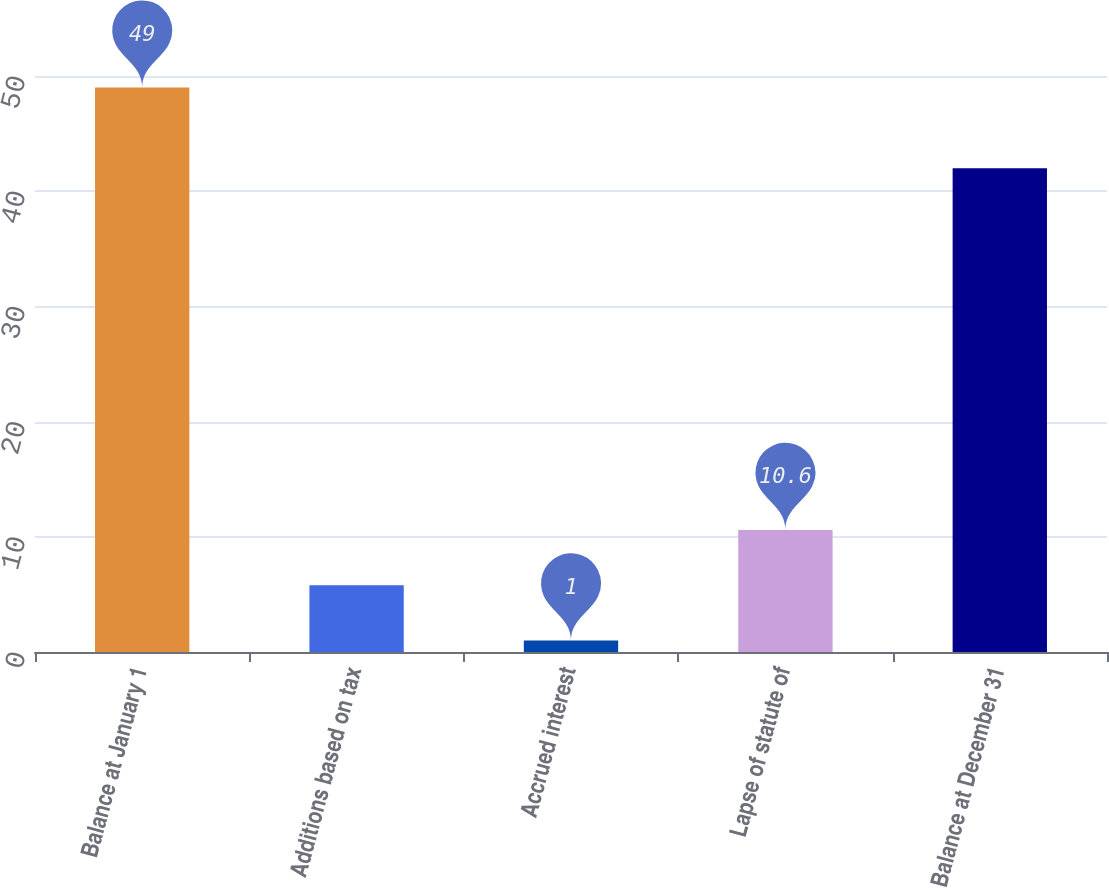<chart> <loc_0><loc_0><loc_500><loc_500><bar_chart><fcel>Balance at January 1<fcel>Additions based on tax<fcel>Accrued interest<fcel>Lapse of statute of<fcel>Balance at December 31<nl><fcel>49<fcel>5.8<fcel>1<fcel>10.6<fcel>42<nl></chart> 